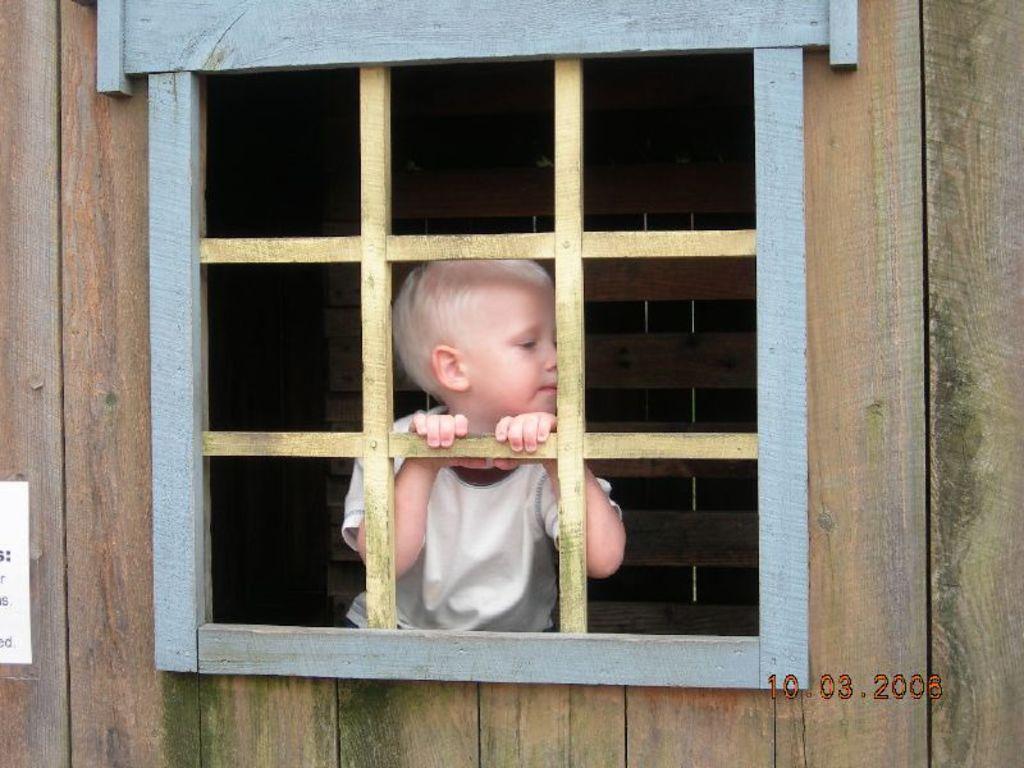Please provide a concise description of this image. In this image in the center there is a window and a wooden wall, in the foreground and there is one boy behind the window and some wooden sticks. On the left side of the image there is some poster, and at the bottom of the image there is text. 